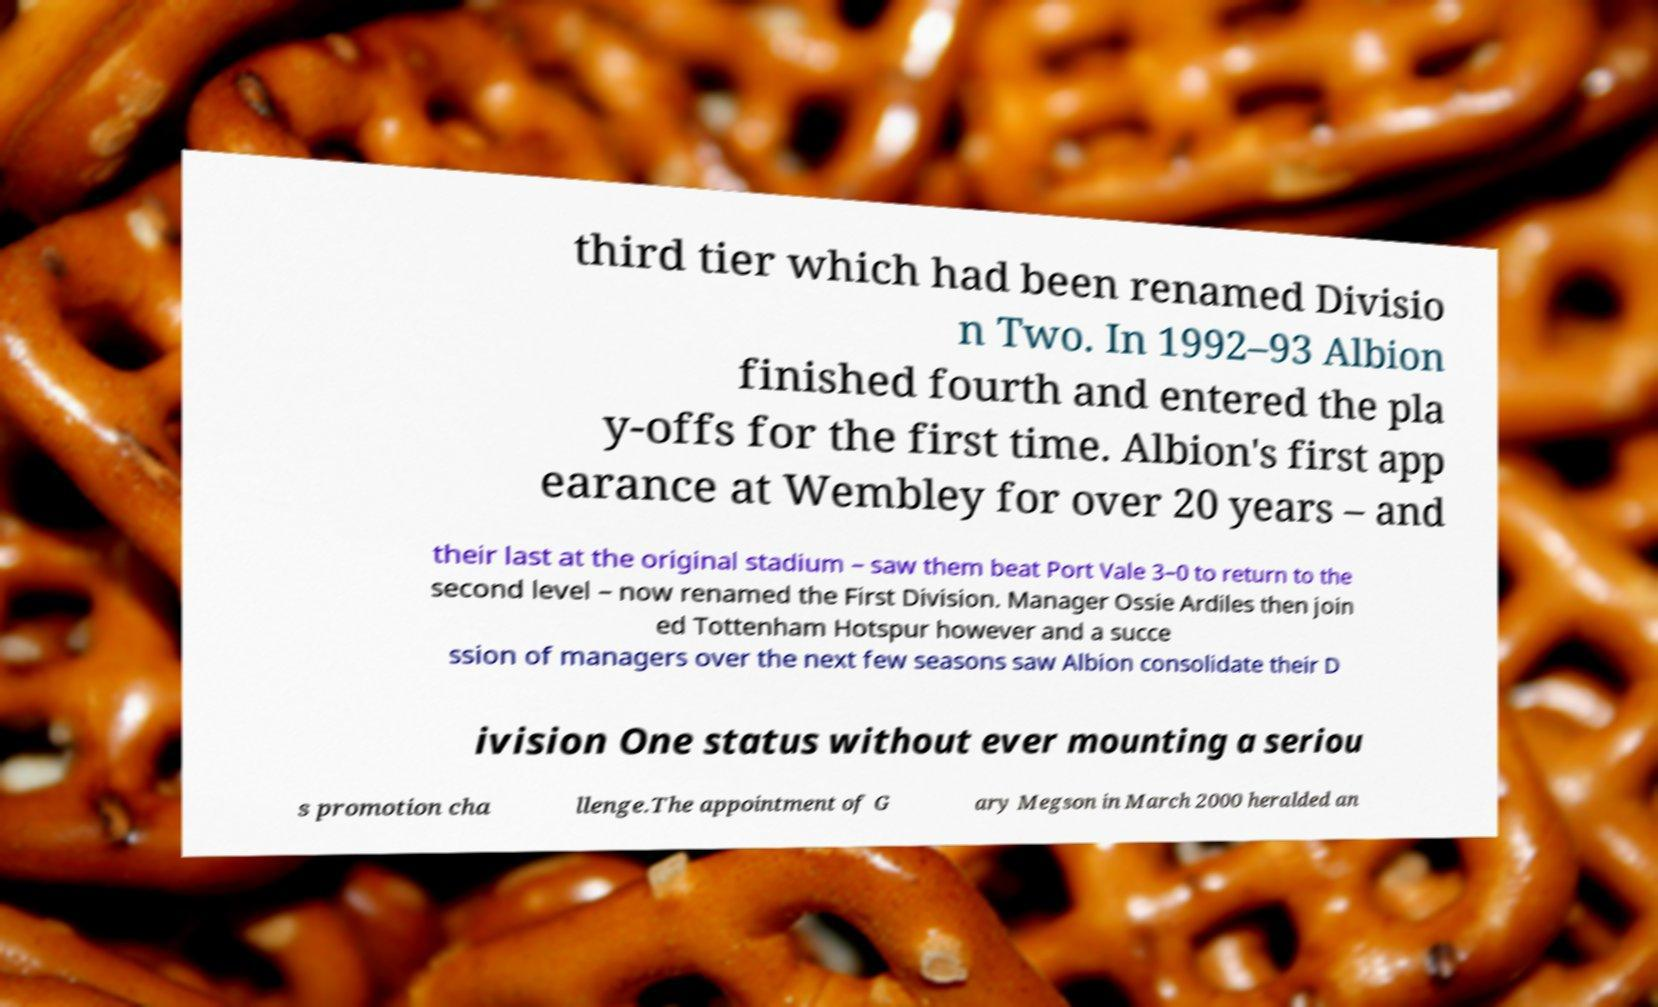I need the written content from this picture converted into text. Can you do that? third tier which had been renamed Divisio n Two. In 1992–93 Albion finished fourth and entered the pla y-offs for the first time. Albion's first app earance at Wembley for over 20 years – and their last at the original stadium – saw them beat Port Vale 3–0 to return to the second level – now renamed the First Division. Manager Ossie Ardiles then join ed Tottenham Hotspur however and a succe ssion of managers over the next few seasons saw Albion consolidate their D ivision One status without ever mounting a seriou s promotion cha llenge.The appointment of G ary Megson in March 2000 heralded an 